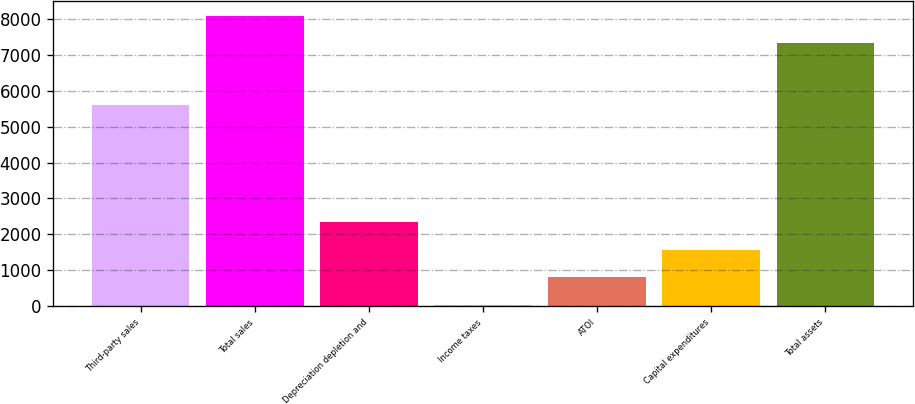Convert chart. <chart><loc_0><loc_0><loc_500><loc_500><bar_chart><fcel>Third-party sales<fcel>Total sales<fcel>Depreciation depletion and<fcel>Income taxes<fcel>ATOI<fcel>Capital expenditures<fcel>Total assets<nl><fcel>5591<fcel>8097.3<fcel>2347.9<fcel>28<fcel>801.3<fcel>1574.6<fcel>7324<nl></chart> 